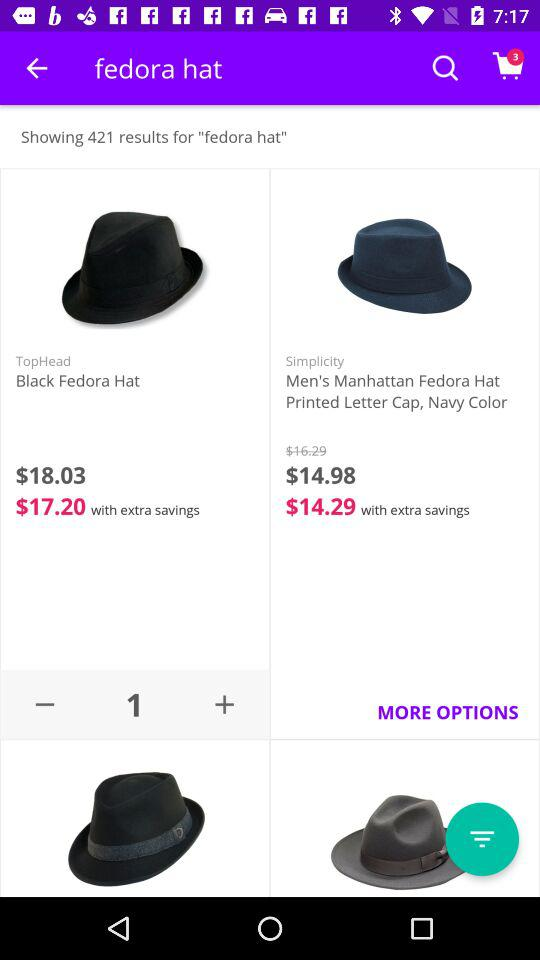Which hat is favorited?
When the provided information is insufficient, respond with <no answer>. <no answer> 